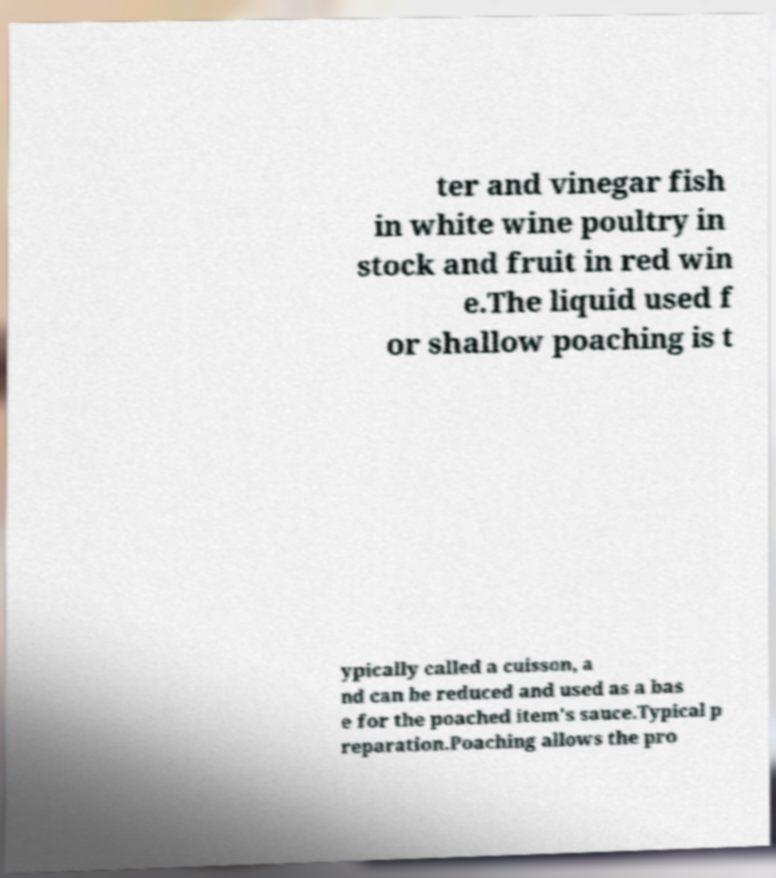For documentation purposes, I need the text within this image transcribed. Could you provide that? ter and vinegar fish in white wine poultry in stock and fruit in red win e.The liquid used f or shallow poaching is t ypically called a cuisson, a nd can be reduced and used as a bas e for the poached item's sauce.Typical p reparation.Poaching allows the pro 